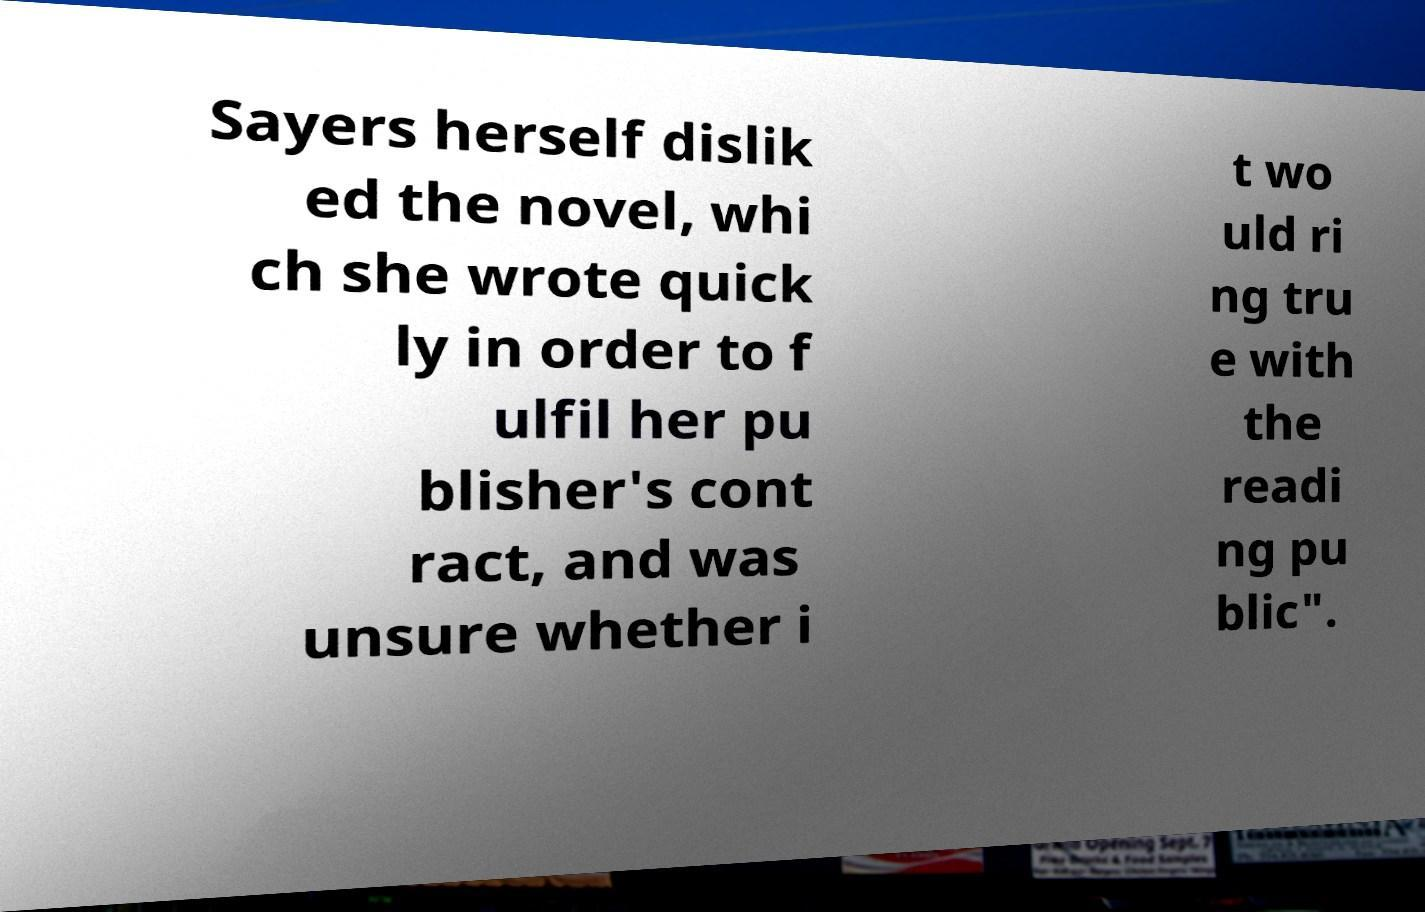Please identify and transcribe the text found in this image. Sayers herself dislik ed the novel, whi ch she wrote quick ly in order to f ulfil her pu blisher's cont ract, and was unsure whether i t wo uld ri ng tru e with the readi ng pu blic". 